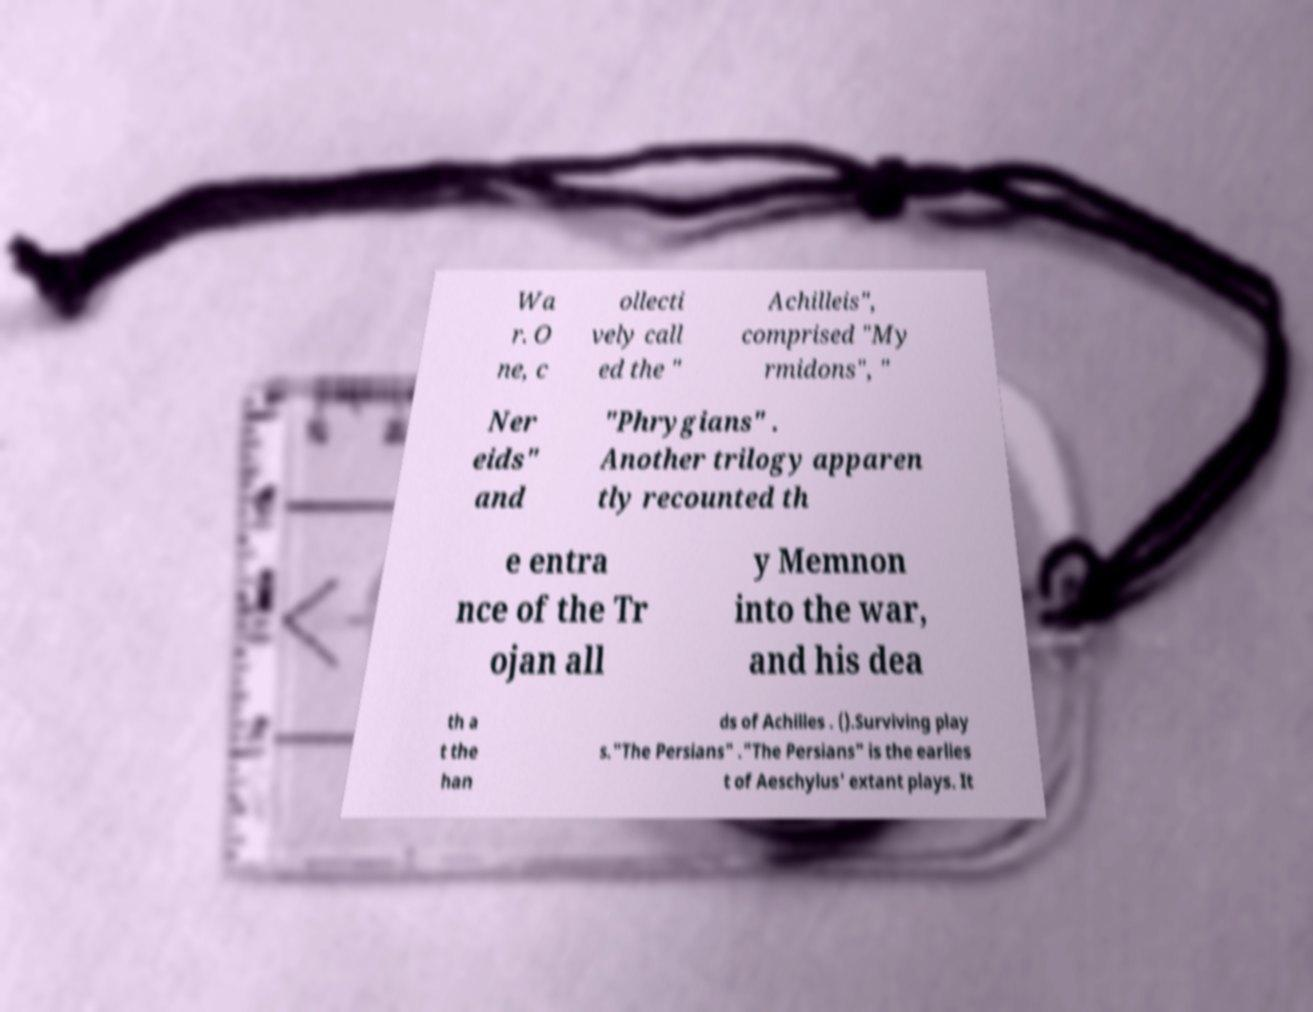Could you assist in decoding the text presented in this image and type it out clearly? Wa r. O ne, c ollecti vely call ed the " Achilleis", comprised "My rmidons", " Ner eids" and "Phrygians" . Another trilogy apparen tly recounted th e entra nce of the Tr ojan all y Memnon into the war, and his dea th a t the han ds of Achilles . ().Surviving play s."The Persians" ."The Persians" is the earlies t of Aeschylus' extant plays. It 